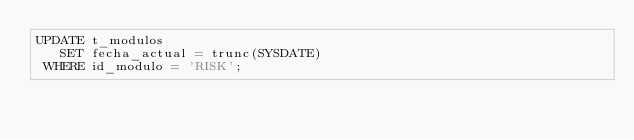Convert code to text. <code><loc_0><loc_0><loc_500><loc_500><_SQL_>UPDATE t_modulos
   SET fecha_actual = trunc(SYSDATE)
 WHERE id_modulo = 'RISK';
</code> 